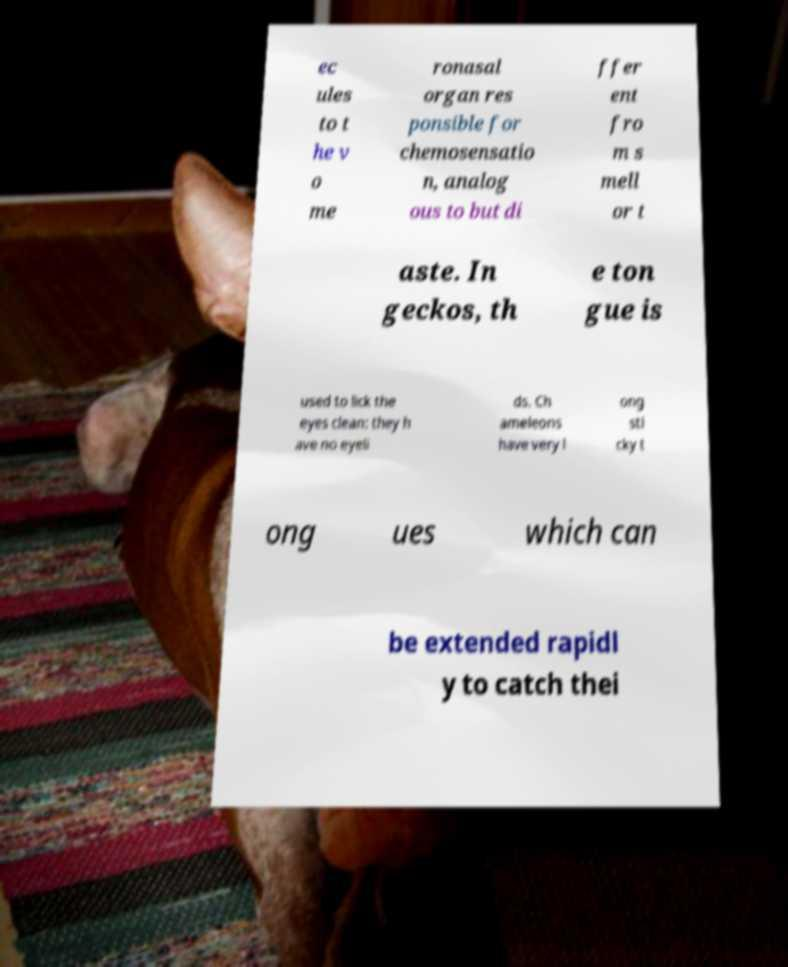Please identify and transcribe the text found in this image. ec ules to t he v o me ronasal organ res ponsible for chemosensatio n, analog ous to but di ffer ent fro m s mell or t aste. In geckos, th e ton gue is used to lick the eyes clean: they h ave no eyeli ds. Ch ameleons have very l ong sti cky t ong ues which can be extended rapidl y to catch thei 